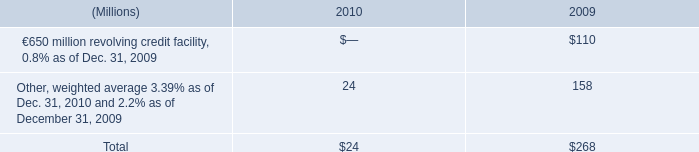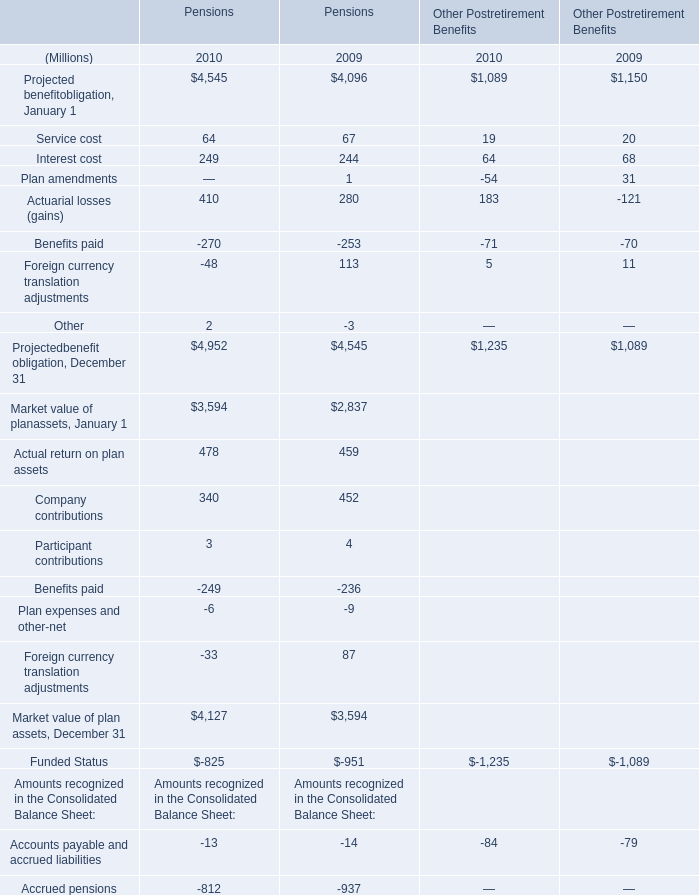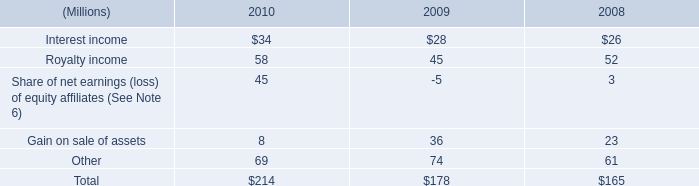In the year with the most Interest cost for Pensions, what is the growth rate of Service cost for Pensions? 
Computations: ((64 - 67) / 67)
Answer: -0.04478. 